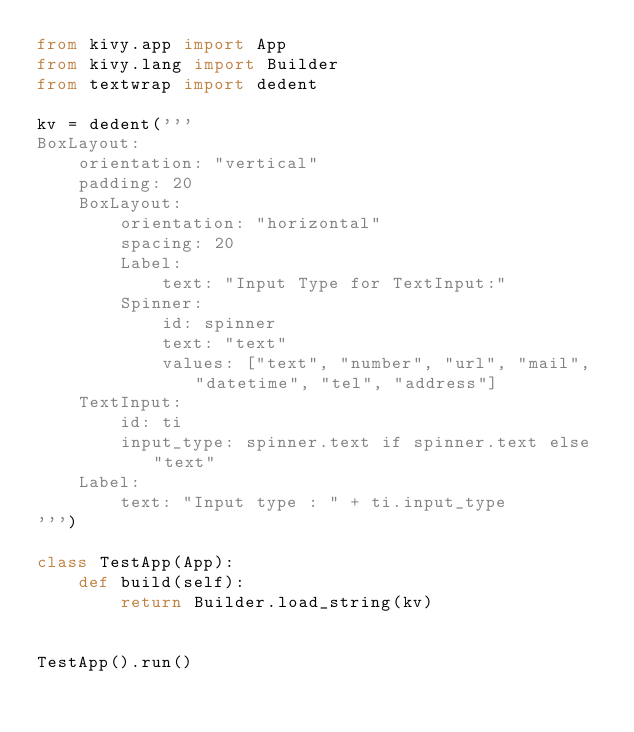<code> <loc_0><loc_0><loc_500><loc_500><_Python_>from kivy.app import App
from kivy.lang import Builder
from textwrap import dedent

kv = dedent('''
BoxLayout:
    orientation: "vertical"
    padding: 20
    BoxLayout:
        orientation: "horizontal"
        spacing: 20
        Label:
            text: "Input Type for TextInput:"
        Spinner:
            id: spinner
            text: "text"
            values: ["text", "number", "url", "mail", "datetime", "tel", "address"]
    TextInput:
        id: ti
        input_type: spinner.text if spinner.text else "text"
    Label:
        text: "Input type : " + ti.input_type
''')

class TestApp(App):
    def build(self):
        return Builder.load_string(kv)


TestApp().run()
</code> 